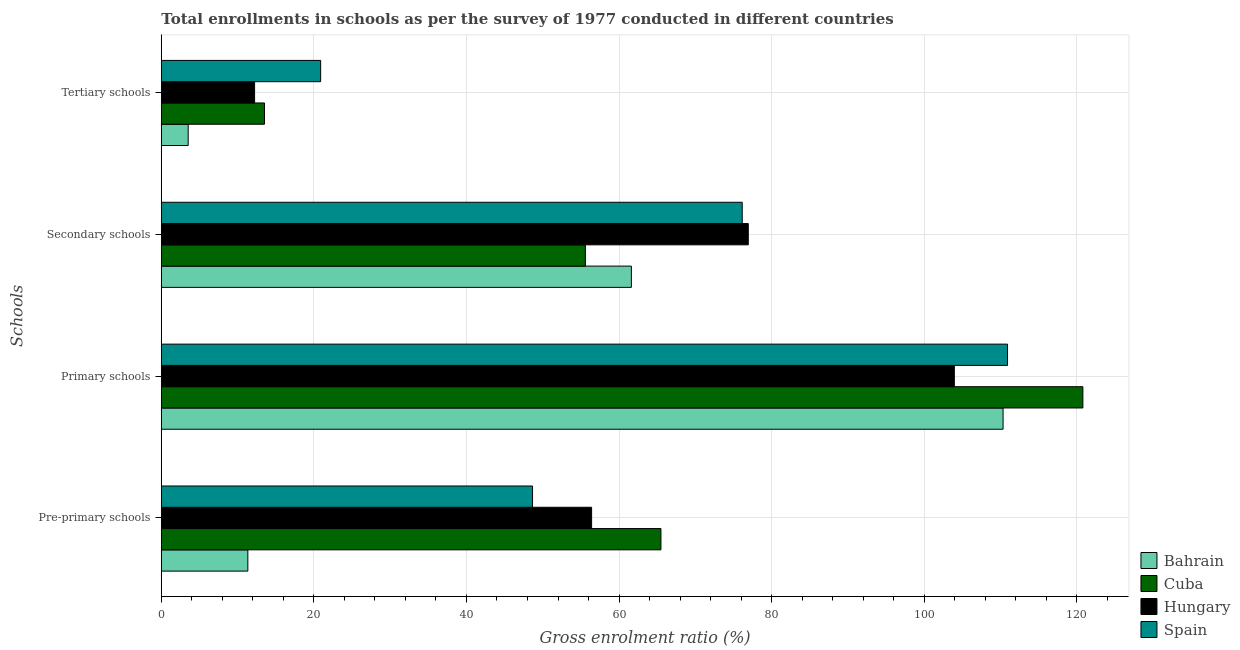How many different coloured bars are there?
Offer a terse response. 4. How many bars are there on the 2nd tick from the top?
Provide a succinct answer. 4. How many bars are there on the 2nd tick from the bottom?
Ensure brevity in your answer.  4. What is the label of the 4th group of bars from the top?
Your answer should be compact. Pre-primary schools. What is the gross enrolment ratio in tertiary schools in Hungary?
Provide a short and direct response. 12.23. Across all countries, what is the maximum gross enrolment ratio in primary schools?
Keep it short and to the point. 120.8. Across all countries, what is the minimum gross enrolment ratio in primary schools?
Your response must be concise. 103.95. In which country was the gross enrolment ratio in secondary schools maximum?
Ensure brevity in your answer.  Hungary. In which country was the gross enrolment ratio in tertiary schools minimum?
Ensure brevity in your answer.  Bahrain. What is the total gross enrolment ratio in primary schools in the graph?
Your answer should be very brief. 446.01. What is the difference between the gross enrolment ratio in pre-primary schools in Cuba and that in Bahrain?
Your answer should be very brief. 54.15. What is the difference between the gross enrolment ratio in primary schools in Hungary and the gross enrolment ratio in tertiary schools in Bahrain?
Offer a terse response. 100.43. What is the average gross enrolment ratio in pre-primary schools per country?
Your answer should be compact. 45.47. What is the difference between the gross enrolment ratio in tertiary schools and gross enrolment ratio in pre-primary schools in Spain?
Your response must be concise. -27.78. What is the ratio of the gross enrolment ratio in primary schools in Bahrain to that in Spain?
Your response must be concise. 0.99. Is the gross enrolment ratio in primary schools in Bahrain less than that in Spain?
Ensure brevity in your answer.  Yes. Is the difference between the gross enrolment ratio in tertiary schools in Hungary and Spain greater than the difference between the gross enrolment ratio in primary schools in Hungary and Spain?
Offer a terse response. No. What is the difference between the highest and the second highest gross enrolment ratio in primary schools?
Your response must be concise. 9.87. What is the difference between the highest and the lowest gross enrolment ratio in tertiary schools?
Provide a succinct answer. 17.36. In how many countries, is the gross enrolment ratio in tertiary schools greater than the average gross enrolment ratio in tertiary schools taken over all countries?
Keep it short and to the point. 2. Is the sum of the gross enrolment ratio in secondary schools in Cuba and Spain greater than the maximum gross enrolment ratio in pre-primary schools across all countries?
Your answer should be very brief. Yes. Is it the case that in every country, the sum of the gross enrolment ratio in tertiary schools and gross enrolment ratio in secondary schools is greater than the sum of gross enrolment ratio in pre-primary schools and gross enrolment ratio in primary schools?
Keep it short and to the point. No. What does the 4th bar from the top in Pre-primary schools represents?
Keep it short and to the point. Bahrain. What does the 4th bar from the bottom in Primary schools represents?
Provide a succinct answer. Spain. Are the values on the major ticks of X-axis written in scientific E-notation?
Provide a succinct answer. No. How many legend labels are there?
Give a very brief answer. 4. How are the legend labels stacked?
Offer a terse response. Vertical. What is the title of the graph?
Provide a short and direct response. Total enrollments in schools as per the survey of 1977 conducted in different countries. Does "United Kingdom" appear as one of the legend labels in the graph?
Offer a very short reply. No. What is the label or title of the Y-axis?
Make the answer very short. Schools. What is the Gross enrolment ratio (%) in Bahrain in Pre-primary schools?
Ensure brevity in your answer.  11.34. What is the Gross enrolment ratio (%) of Cuba in Pre-primary schools?
Your answer should be very brief. 65.49. What is the Gross enrolment ratio (%) in Hungary in Pre-primary schools?
Provide a succinct answer. 56.4. What is the Gross enrolment ratio (%) of Spain in Pre-primary schools?
Provide a short and direct response. 48.66. What is the Gross enrolment ratio (%) of Bahrain in Primary schools?
Provide a succinct answer. 110.34. What is the Gross enrolment ratio (%) in Cuba in Primary schools?
Make the answer very short. 120.8. What is the Gross enrolment ratio (%) of Hungary in Primary schools?
Provide a succinct answer. 103.95. What is the Gross enrolment ratio (%) in Spain in Primary schools?
Make the answer very short. 110.92. What is the Gross enrolment ratio (%) in Bahrain in Secondary schools?
Make the answer very short. 61.62. What is the Gross enrolment ratio (%) in Cuba in Secondary schools?
Give a very brief answer. 55.59. What is the Gross enrolment ratio (%) of Hungary in Secondary schools?
Keep it short and to the point. 76.94. What is the Gross enrolment ratio (%) in Spain in Secondary schools?
Ensure brevity in your answer.  76.15. What is the Gross enrolment ratio (%) in Bahrain in Tertiary schools?
Your answer should be very brief. 3.52. What is the Gross enrolment ratio (%) in Cuba in Tertiary schools?
Ensure brevity in your answer.  13.53. What is the Gross enrolment ratio (%) in Hungary in Tertiary schools?
Offer a terse response. 12.23. What is the Gross enrolment ratio (%) of Spain in Tertiary schools?
Make the answer very short. 20.88. Across all Schools, what is the maximum Gross enrolment ratio (%) of Bahrain?
Provide a succinct answer. 110.34. Across all Schools, what is the maximum Gross enrolment ratio (%) in Cuba?
Give a very brief answer. 120.8. Across all Schools, what is the maximum Gross enrolment ratio (%) of Hungary?
Give a very brief answer. 103.95. Across all Schools, what is the maximum Gross enrolment ratio (%) in Spain?
Provide a short and direct response. 110.92. Across all Schools, what is the minimum Gross enrolment ratio (%) in Bahrain?
Ensure brevity in your answer.  3.52. Across all Schools, what is the minimum Gross enrolment ratio (%) of Cuba?
Your answer should be compact. 13.53. Across all Schools, what is the minimum Gross enrolment ratio (%) in Hungary?
Provide a succinct answer. 12.23. Across all Schools, what is the minimum Gross enrolment ratio (%) of Spain?
Your response must be concise. 20.88. What is the total Gross enrolment ratio (%) of Bahrain in the graph?
Your answer should be compact. 186.82. What is the total Gross enrolment ratio (%) of Cuba in the graph?
Make the answer very short. 255.4. What is the total Gross enrolment ratio (%) of Hungary in the graph?
Offer a very short reply. 249.52. What is the total Gross enrolment ratio (%) of Spain in the graph?
Provide a succinct answer. 256.62. What is the difference between the Gross enrolment ratio (%) in Bahrain in Pre-primary schools and that in Primary schools?
Make the answer very short. -99. What is the difference between the Gross enrolment ratio (%) of Cuba in Pre-primary schools and that in Primary schools?
Your response must be concise. -55.31. What is the difference between the Gross enrolment ratio (%) of Hungary in Pre-primary schools and that in Primary schools?
Provide a succinct answer. -47.55. What is the difference between the Gross enrolment ratio (%) of Spain in Pre-primary schools and that in Primary schools?
Your answer should be compact. -62.26. What is the difference between the Gross enrolment ratio (%) of Bahrain in Pre-primary schools and that in Secondary schools?
Give a very brief answer. -50.27. What is the difference between the Gross enrolment ratio (%) of Cuba in Pre-primary schools and that in Secondary schools?
Your response must be concise. 9.9. What is the difference between the Gross enrolment ratio (%) of Hungary in Pre-primary schools and that in Secondary schools?
Provide a short and direct response. -20.54. What is the difference between the Gross enrolment ratio (%) of Spain in Pre-primary schools and that in Secondary schools?
Your response must be concise. -27.49. What is the difference between the Gross enrolment ratio (%) in Bahrain in Pre-primary schools and that in Tertiary schools?
Your response must be concise. 7.82. What is the difference between the Gross enrolment ratio (%) in Cuba in Pre-primary schools and that in Tertiary schools?
Make the answer very short. 51.97. What is the difference between the Gross enrolment ratio (%) in Hungary in Pre-primary schools and that in Tertiary schools?
Provide a succinct answer. 44.18. What is the difference between the Gross enrolment ratio (%) of Spain in Pre-primary schools and that in Tertiary schools?
Offer a very short reply. 27.78. What is the difference between the Gross enrolment ratio (%) of Bahrain in Primary schools and that in Secondary schools?
Offer a terse response. 48.72. What is the difference between the Gross enrolment ratio (%) of Cuba in Primary schools and that in Secondary schools?
Offer a terse response. 65.21. What is the difference between the Gross enrolment ratio (%) in Hungary in Primary schools and that in Secondary schools?
Give a very brief answer. 27.01. What is the difference between the Gross enrolment ratio (%) in Spain in Primary schools and that in Secondary schools?
Give a very brief answer. 34.78. What is the difference between the Gross enrolment ratio (%) in Bahrain in Primary schools and that in Tertiary schools?
Make the answer very short. 106.82. What is the difference between the Gross enrolment ratio (%) of Cuba in Primary schools and that in Tertiary schools?
Offer a very short reply. 107.27. What is the difference between the Gross enrolment ratio (%) of Hungary in Primary schools and that in Tertiary schools?
Ensure brevity in your answer.  91.72. What is the difference between the Gross enrolment ratio (%) of Spain in Primary schools and that in Tertiary schools?
Your response must be concise. 90.04. What is the difference between the Gross enrolment ratio (%) of Bahrain in Secondary schools and that in Tertiary schools?
Provide a short and direct response. 58.1. What is the difference between the Gross enrolment ratio (%) of Cuba in Secondary schools and that in Tertiary schools?
Keep it short and to the point. 42.06. What is the difference between the Gross enrolment ratio (%) of Hungary in Secondary schools and that in Tertiary schools?
Keep it short and to the point. 64.71. What is the difference between the Gross enrolment ratio (%) in Spain in Secondary schools and that in Tertiary schools?
Your answer should be very brief. 55.26. What is the difference between the Gross enrolment ratio (%) of Bahrain in Pre-primary schools and the Gross enrolment ratio (%) of Cuba in Primary schools?
Your answer should be very brief. -109.46. What is the difference between the Gross enrolment ratio (%) in Bahrain in Pre-primary schools and the Gross enrolment ratio (%) in Hungary in Primary schools?
Offer a terse response. -92.61. What is the difference between the Gross enrolment ratio (%) in Bahrain in Pre-primary schools and the Gross enrolment ratio (%) in Spain in Primary schools?
Provide a short and direct response. -99.58. What is the difference between the Gross enrolment ratio (%) of Cuba in Pre-primary schools and the Gross enrolment ratio (%) of Hungary in Primary schools?
Keep it short and to the point. -38.46. What is the difference between the Gross enrolment ratio (%) of Cuba in Pre-primary schools and the Gross enrolment ratio (%) of Spain in Primary schools?
Ensure brevity in your answer.  -45.43. What is the difference between the Gross enrolment ratio (%) of Hungary in Pre-primary schools and the Gross enrolment ratio (%) of Spain in Primary schools?
Your answer should be very brief. -54.52. What is the difference between the Gross enrolment ratio (%) of Bahrain in Pre-primary schools and the Gross enrolment ratio (%) of Cuba in Secondary schools?
Give a very brief answer. -44.25. What is the difference between the Gross enrolment ratio (%) of Bahrain in Pre-primary schools and the Gross enrolment ratio (%) of Hungary in Secondary schools?
Your response must be concise. -65.6. What is the difference between the Gross enrolment ratio (%) of Bahrain in Pre-primary schools and the Gross enrolment ratio (%) of Spain in Secondary schools?
Make the answer very short. -64.81. What is the difference between the Gross enrolment ratio (%) in Cuba in Pre-primary schools and the Gross enrolment ratio (%) in Hungary in Secondary schools?
Give a very brief answer. -11.45. What is the difference between the Gross enrolment ratio (%) of Cuba in Pre-primary schools and the Gross enrolment ratio (%) of Spain in Secondary schools?
Give a very brief answer. -10.66. What is the difference between the Gross enrolment ratio (%) in Hungary in Pre-primary schools and the Gross enrolment ratio (%) in Spain in Secondary schools?
Your answer should be compact. -19.74. What is the difference between the Gross enrolment ratio (%) of Bahrain in Pre-primary schools and the Gross enrolment ratio (%) of Cuba in Tertiary schools?
Keep it short and to the point. -2.18. What is the difference between the Gross enrolment ratio (%) in Bahrain in Pre-primary schools and the Gross enrolment ratio (%) in Hungary in Tertiary schools?
Ensure brevity in your answer.  -0.88. What is the difference between the Gross enrolment ratio (%) in Bahrain in Pre-primary schools and the Gross enrolment ratio (%) in Spain in Tertiary schools?
Offer a terse response. -9.54. What is the difference between the Gross enrolment ratio (%) of Cuba in Pre-primary schools and the Gross enrolment ratio (%) of Hungary in Tertiary schools?
Keep it short and to the point. 53.27. What is the difference between the Gross enrolment ratio (%) of Cuba in Pre-primary schools and the Gross enrolment ratio (%) of Spain in Tertiary schools?
Ensure brevity in your answer.  44.61. What is the difference between the Gross enrolment ratio (%) of Hungary in Pre-primary schools and the Gross enrolment ratio (%) of Spain in Tertiary schools?
Offer a terse response. 35.52. What is the difference between the Gross enrolment ratio (%) of Bahrain in Primary schools and the Gross enrolment ratio (%) of Cuba in Secondary schools?
Offer a very short reply. 54.75. What is the difference between the Gross enrolment ratio (%) of Bahrain in Primary schools and the Gross enrolment ratio (%) of Hungary in Secondary schools?
Provide a succinct answer. 33.4. What is the difference between the Gross enrolment ratio (%) of Bahrain in Primary schools and the Gross enrolment ratio (%) of Spain in Secondary schools?
Keep it short and to the point. 34.19. What is the difference between the Gross enrolment ratio (%) in Cuba in Primary schools and the Gross enrolment ratio (%) in Hungary in Secondary schools?
Offer a terse response. 43.86. What is the difference between the Gross enrolment ratio (%) in Cuba in Primary schools and the Gross enrolment ratio (%) in Spain in Secondary schools?
Ensure brevity in your answer.  44.65. What is the difference between the Gross enrolment ratio (%) in Hungary in Primary schools and the Gross enrolment ratio (%) in Spain in Secondary schools?
Ensure brevity in your answer.  27.8. What is the difference between the Gross enrolment ratio (%) in Bahrain in Primary schools and the Gross enrolment ratio (%) in Cuba in Tertiary schools?
Ensure brevity in your answer.  96.81. What is the difference between the Gross enrolment ratio (%) of Bahrain in Primary schools and the Gross enrolment ratio (%) of Hungary in Tertiary schools?
Your response must be concise. 98.11. What is the difference between the Gross enrolment ratio (%) in Bahrain in Primary schools and the Gross enrolment ratio (%) in Spain in Tertiary schools?
Keep it short and to the point. 89.46. What is the difference between the Gross enrolment ratio (%) in Cuba in Primary schools and the Gross enrolment ratio (%) in Hungary in Tertiary schools?
Give a very brief answer. 108.57. What is the difference between the Gross enrolment ratio (%) in Cuba in Primary schools and the Gross enrolment ratio (%) in Spain in Tertiary schools?
Ensure brevity in your answer.  99.91. What is the difference between the Gross enrolment ratio (%) of Hungary in Primary schools and the Gross enrolment ratio (%) of Spain in Tertiary schools?
Offer a terse response. 83.07. What is the difference between the Gross enrolment ratio (%) in Bahrain in Secondary schools and the Gross enrolment ratio (%) in Cuba in Tertiary schools?
Make the answer very short. 48.09. What is the difference between the Gross enrolment ratio (%) of Bahrain in Secondary schools and the Gross enrolment ratio (%) of Hungary in Tertiary schools?
Ensure brevity in your answer.  49.39. What is the difference between the Gross enrolment ratio (%) of Bahrain in Secondary schools and the Gross enrolment ratio (%) of Spain in Tertiary schools?
Provide a short and direct response. 40.73. What is the difference between the Gross enrolment ratio (%) in Cuba in Secondary schools and the Gross enrolment ratio (%) in Hungary in Tertiary schools?
Make the answer very short. 43.36. What is the difference between the Gross enrolment ratio (%) in Cuba in Secondary schools and the Gross enrolment ratio (%) in Spain in Tertiary schools?
Make the answer very short. 34.7. What is the difference between the Gross enrolment ratio (%) of Hungary in Secondary schools and the Gross enrolment ratio (%) of Spain in Tertiary schools?
Offer a very short reply. 56.06. What is the average Gross enrolment ratio (%) in Bahrain per Schools?
Ensure brevity in your answer.  46.7. What is the average Gross enrolment ratio (%) of Cuba per Schools?
Your answer should be very brief. 63.85. What is the average Gross enrolment ratio (%) in Hungary per Schools?
Provide a succinct answer. 62.38. What is the average Gross enrolment ratio (%) in Spain per Schools?
Offer a very short reply. 64.15. What is the difference between the Gross enrolment ratio (%) of Bahrain and Gross enrolment ratio (%) of Cuba in Pre-primary schools?
Keep it short and to the point. -54.15. What is the difference between the Gross enrolment ratio (%) in Bahrain and Gross enrolment ratio (%) in Hungary in Pre-primary schools?
Your answer should be compact. -45.06. What is the difference between the Gross enrolment ratio (%) in Bahrain and Gross enrolment ratio (%) in Spain in Pre-primary schools?
Your response must be concise. -37.32. What is the difference between the Gross enrolment ratio (%) of Cuba and Gross enrolment ratio (%) of Hungary in Pre-primary schools?
Make the answer very short. 9.09. What is the difference between the Gross enrolment ratio (%) of Cuba and Gross enrolment ratio (%) of Spain in Pre-primary schools?
Your answer should be very brief. 16.83. What is the difference between the Gross enrolment ratio (%) of Hungary and Gross enrolment ratio (%) of Spain in Pre-primary schools?
Offer a terse response. 7.74. What is the difference between the Gross enrolment ratio (%) of Bahrain and Gross enrolment ratio (%) of Cuba in Primary schools?
Offer a terse response. -10.46. What is the difference between the Gross enrolment ratio (%) of Bahrain and Gross enrolment ratio (%) of Hungary in Primary schools?
Offer a terse response. 6.39. What is the difference between the Gross enrolment ratio (%) in Bahrain and Gross enrolment ratio (%) in Spain in Primary schools?
Give a very brief answer. -0.58. What is the difference between the Gross enrolment ratio (%) of Cuba and Gross enrolment ratio (%) of Hungary in Primary schools?
Your answer should be compact. 16.85. What is the difference between the Gross enrolment ratio (%) in Cuba and Gross enrolment ratio (%) in Spain in Primary schools?
Keep it short and to the point. 9.87. What is the difference between the Gross enrolment ratio (%) of Hungary and Gross enrolment ratio (%) of Spain in Primary schools?
Offer a terse response. -6.97. What is the difference between the Gross enrolment ratio (%) of Bahrain and Gross enrolment ratio (%) of Cuba in Secondary schools?
Your answer should be compact. 6.03. What is the difference between the Gross enrolment ratio (%) in Bahrain and Gross enrolment ratio (%) in Hungary in Secondary schools?
Make the answer very short. -15.32. What is the difference between the Gross enrolment ratio (%) in Bahrain and Gross enrolment ratio (%) in Spain in Secondary schools?
Give a very brief answer. -14.53. What is the difference between the Gross enrolment ratio (%) in Cuba and Gross enrolment ratio (%) in Hungary in Secondary schools?
Your answer should be very brief. -21.35. What is the difference between the Gross enrolment ratio (%) of Cuba and Gross enrolment ratio (%) of Spain in Secondary schools?
Make the answer very short. -20.56. What is the difference between the Gross enrolment ratio (%) in Hungary and Gross enrolment ratio (%) in Spain in Secondary schools?
Provide a succinct answer. 0.79. What is the difference between the Gross enrolment ratio (%) in Bahrain and Gross enrolment ratio (%) in Cuba in Tertiary schools?
Your answer should be very brief. -10. What is the difference between the Gross enrolment ratio (%) of Bahrain and Gross enrolment ratio (%) of Hungary in Tertiary schools?
Your answer should be very brief. -8.7. What is the difference between the Gross enrolment ratio (%) in Bahrain and Gross enrolment ratio (%) in Spain in Tertiary schools?
Offer a very short reply. -17.36. What is the difference between the Gross enrolment ratio (%) in Cuba and Gross enrolment ratio (%) in Hungary in Tertiary schools?
Keep it short and to the point. 1.3. What is the difference between the Gross enrolment ratio (%) in Cuba and Gross enrolment ratio (%) in Spain in Tertiary schools?
Keep it short and to the point. -7.36. What is the difference between the Gross enrolment ratio (%) in Hungary and Gross enrolment ratio (%) in Spain in Tertiary schools?
Your answer should be compact. -8.66. What is the ratio of the Gross enrolment ratio (%) of Bahrain in Pre-primary schools to that in Primary schools?
Offer a terse response. 0.1. What is the ratio of the Gross enrolment ratio (%) in Cuba in Pre-primary schools to that in Primary schools?
Your answer should be compact. 0.54. What is the ratio of the Gross enrolment ratio (%) in Hungary in Pre-primary schools to that in Primary schools?
Offer a terse response. 0.54. What is the ratio of the Gross enrolment ratio (%) in Spain in Pre-primary schools to that in Primary schools?
Provide a succinct answer. 0.44. What is the ratio of the Gross enrolment ratio (%) of Bahrain in Pre-primary schools to that in Secondary schools?
Your answer should be very brief. 0.18. What is the ratio of the Gross enrolment ratio (%) in Cuba in Pre-primary schools to that in Secondary schools?
Ensure brevity in your answer.  1.18. What is the ratio of the Gross enrolment ratio (%) of Hungary in Pre-primary schools to that in Secondary schools?
Give a very brief answer. 0.73. What is the ratio of the Gross enrolment ratio (%) of Spain in Pre-primary schools to that in Secondary schools?
Give a very brief answer. 0.64. What is the ratio of the Gross enrolment ratio (%) in Bahrain in Pre-primary schools to that in Tertiary schools?
Provide a succinct answer. 3.22. What is the ratio of the Gross enrolment ratio (%) of Cuba in Pre-primary schools to that in Tertiary schools?
Give a very brief answer. 4.84. What is the ratio of the Gross enrolment ratio (%) of Hungary in Pre-primary schools to that in Tertiary schools?
Keep it short and to the point. 4.61. What is the ratio of the Gross enrolment ratio (%) in Spain in Pre-primary schools to that in Tertiary schools?
Provide a succinct answer. 2.33. What is the ratio of the Gross enrolment ratio (%) in Bahrain in Primary schools to that in Secondary schools?
Offer a terse response. 1.79. What is the ratio of the Gross enrolment ratio (%) in Cuba in Primary schools to that in Secondary schools?
Offer a very short reply. 2.17. What is the ratio of the Gross enrolment ratio (%) of Hungary in Primary schools to that in Secondary schools?
Give a very brief answer. 1.35. What is the ratio of the Gross enrolment ratio (%) of Spain in Primary schools to that in Secondary schools?
Keep it short and to the point. 1.46. What is the ratio of the Gross enrolment ratio (%) in Bahrain in Primary schools to that in Tertiary schools?
Provide a succinct answer. 31.33. What is the ratio of the Gross enrolment ratio (%) of Cuba in Primary schools to that in Tertiary schools?
Provide a short and direct response. 8.93. What is the ratio of the Gross enrolment ratio (%) of Hungary in Primary schools to that in Tertiary schools?
Provide a short and direct response. 8.5. What is the ratio of the Gross enrolment ratio (%) in Spain in Primary schools to that in Tertiary schools?
Ensure brevity in your answer.  5.31. What is the ratio of the Gross enrolment ratio (%) in Bahrain in Secondary schools to that in Tertiary schools?
Ensure brevity in your answer.  17.5. What is the ratio of the Gross enrolment ratio (%) of Cuba in Secondary schools to that in Tertiary schools?
Keep it short and to the point. 4.11. What is the ratio of the Gross enrolment ratio (%) in Hungary in Secondary schools to that in Tertiary schools?
Your answer should be compact. 6.29. What is the ratio of the Gross enrolment ratio (%) of Spain in Secondary schools to that in Tertiary schools?
Your response must be concise. 3.65. What is the difference between the highest and the second highest Gross enrolment ratio (%) in Bahrain?
Your answer should be very brief. 48.72. What is the difference between the highest and the second highest Gross enrolment ratio (%) in Cuba?
Your answer should be compact. 55.31. What is the difference between the highest and the second highest Gross enrolment ratio (%) of Hungary?
Keep it short and to the point. 27.01. What is the difference between the highest and the second highest Gross enrolment ratio (%) of Spain?
Ensure brevity in your answer.  34.78. What is the difference between the highest and the lowest Gross enrolment ratio (%) of Bahrain?
Ensure brevity in your answer.  106.82. What is the difference between the highest and the lowest Gross enrolment ratio (%) of Cuba?
Offer a very short reply. 107.27. What is the difference between the highest and the lowest Gross enrolment ratio (%) in Hungary?
Provide a short and direct response. 91.72. What is the difference between the highest and the lowest Gross enrolment ratio (%) of Spain?
Offer a terse response. 90.04. 